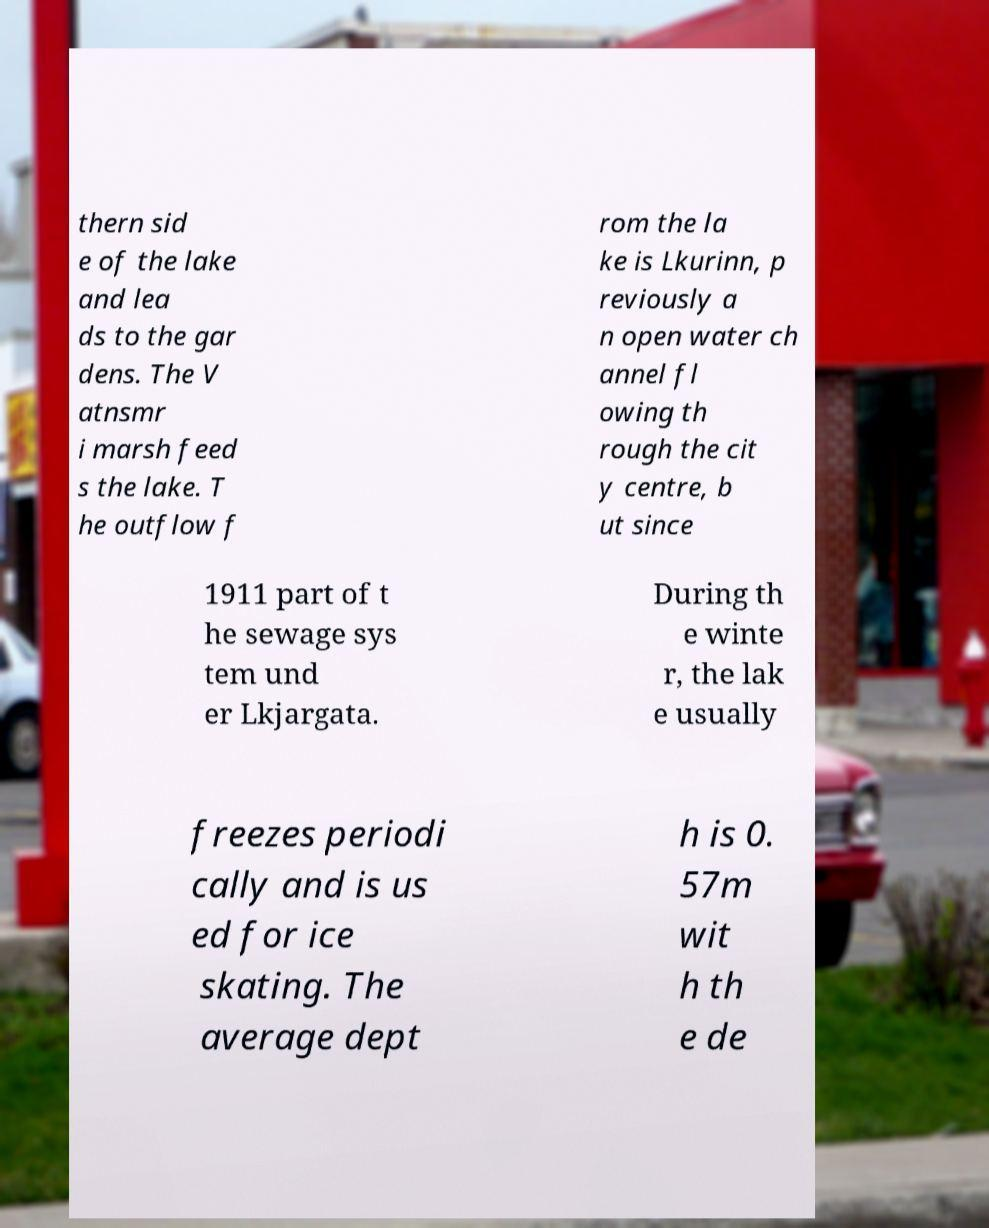Can you read and provide the text displayed in the image?This photo seems to have some interesting text. Can you extract and type it out for me? thern sid e of the lake and lea ds to the gar dens. The V atnsmr i marsh feed s the lake. T he outflow f rom the la ke is Lkurinn, p reviously a n open water ch annel fl owing th rough the cit y centre, b ut since 1911 part of t he sewage sys tem und er Lkjargata. During th e winte r, the lak e usually freezes periodi cally and is us ed for ice skating. The average dept h is 0. 57m wit h th e de 